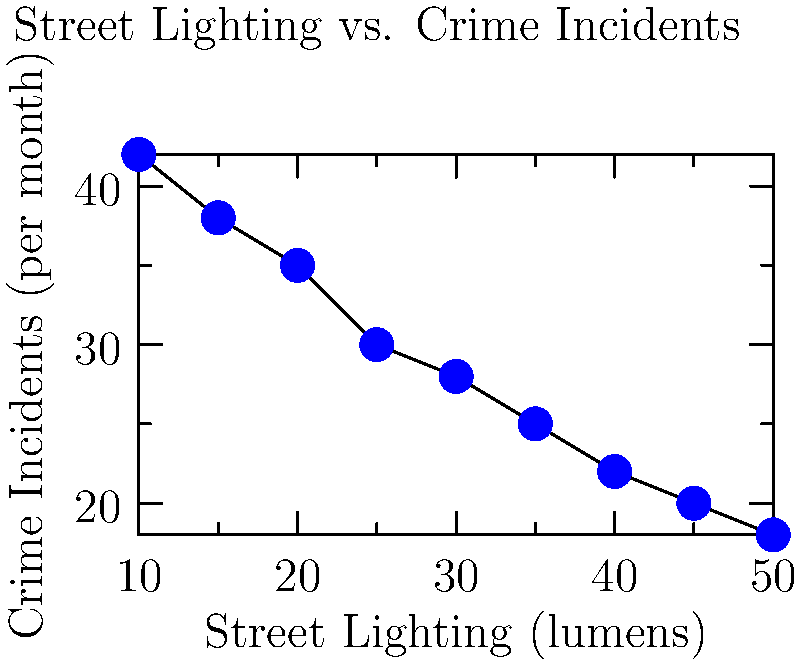Based on the scatter plot showing the relationship between street lighting intensity and monthly crime incidents, what type of correlation is observed, and how might this information be used to address crime concerns in your neighborhood? To answer this question, let's analyze the scatter plot step-by-step:

1. Observe the overall trend: As we move from left to right (increasing street lighting), the number of crime incidents decreases.

2. Identify the correlation type:
   - Negative correlation: As one variable increases, the other decreases.
   - The points form a rough line from top-left to bottom-right.

3. Assess the strength of the correlation:
   - The points follow a clear pattern but with some scatter.
   - This suggests a moderately strong negative correlation.

4. Interpret the data:
   - Increased street lighting (measured in lumens) is associated with fewer crime incidents per month.
   - For example, at 10 lumens, there are about 42 incidents/month, while at 50 lumens, there are about 18 incidents/month.

5. Application to neighborhood crime concerns:
   - This data supports the idea that improving street lighting could help reduce crime.
   - As a neighborhood association leader, you could use this information to:
     a) Advocate for increased street lighting in high-crime areas.
     b) Prioritize budget allocation for lighting improvements.
     c) Develop a targeted crime prevention strategy focusing on poorly lit areas.

6. Consider limitations:
   - Correlation does not imply causation; other factors may influence crime rates.
   - The specific relationship may vary in different neighborhoods or contexts.
Answer: Moderately strong negative correlation; use to advocate for improved street lighting in high-crime areas. 